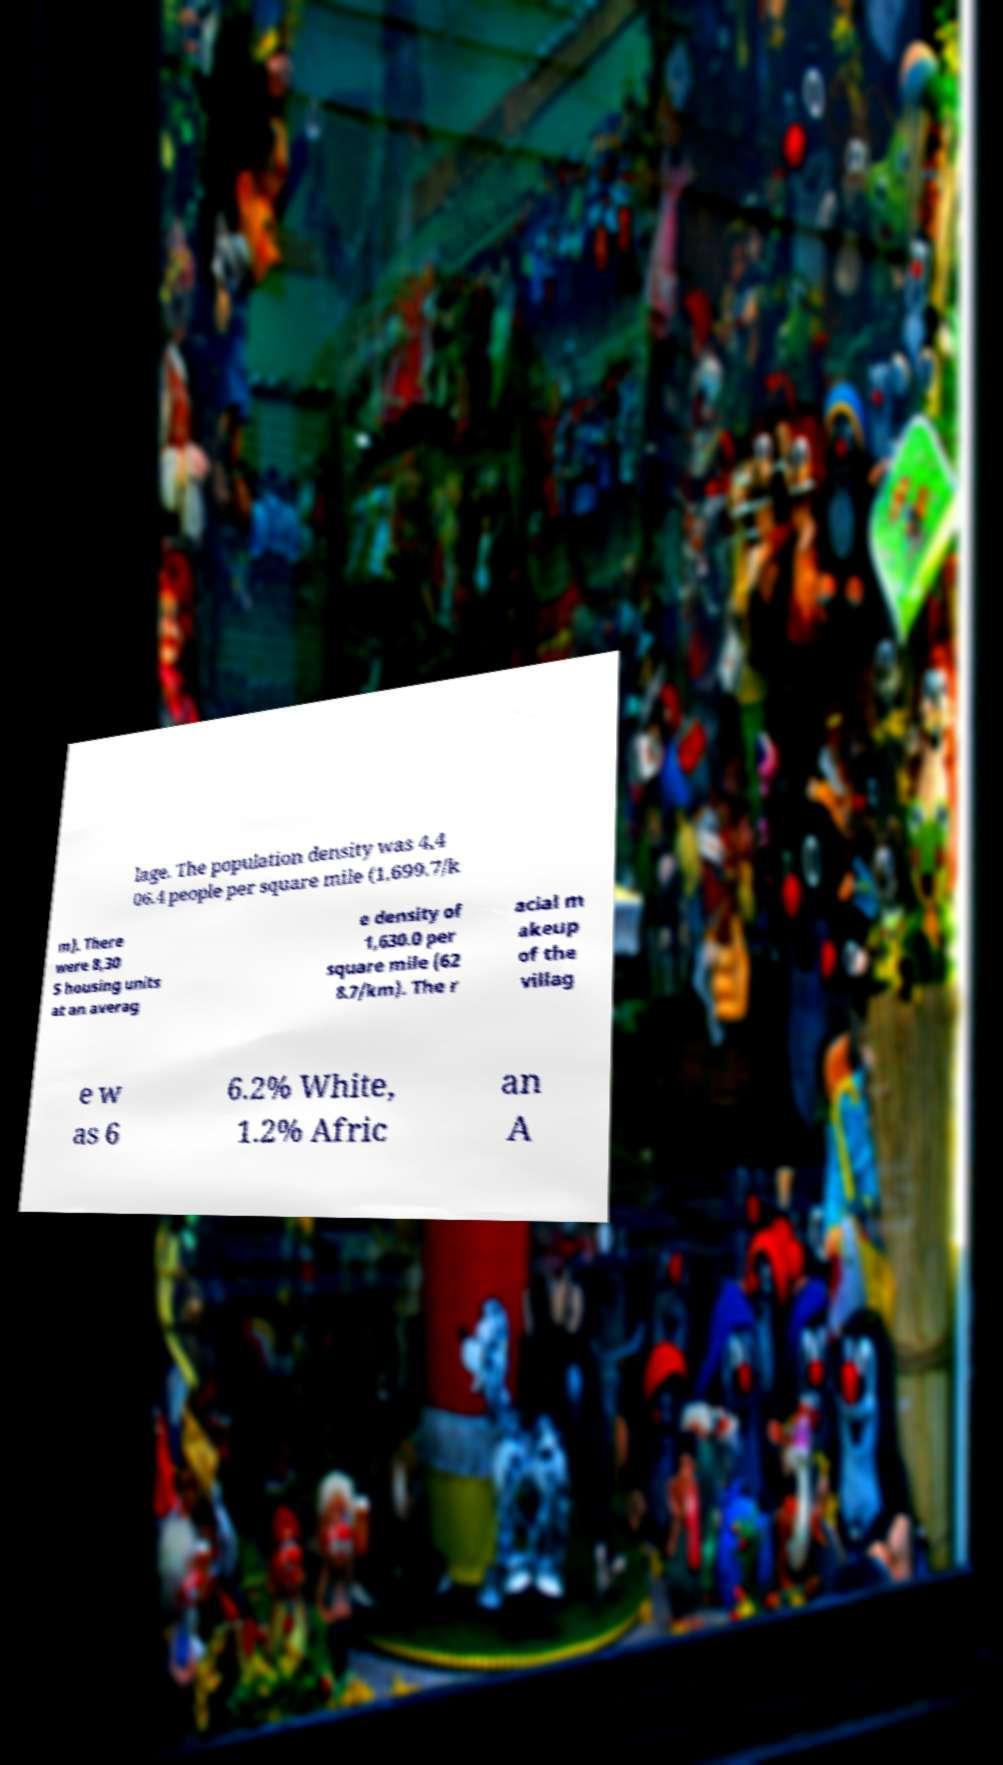Could you extract and type out the text from this image? lage. The population density was 4,4 06.4 people per square mile (1,699.7/k m). There were 8,30 5 housing units at an averag e density of 1,630.0 per square mile (62 8.7/km). The r acial m akeup of the villag e w as 6 6.2% White, 1.2% Afric an A 